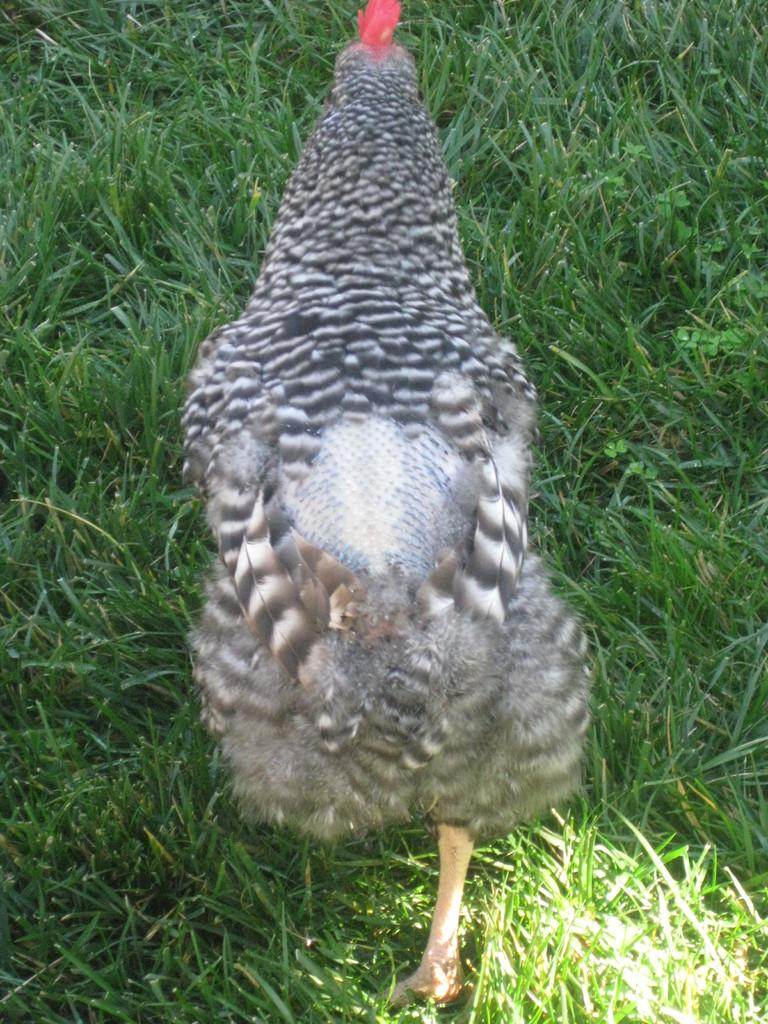What type of animal is in the image? There is a hen in the image. What color is the hen in the image? The hen is in black and white color. What is the hen walking on in the image? The hen is walking on grass in the image. What type of apparel is the hen wearing in the image? There is no apparel present on the hen in the image, as it is a bird and does not wear clothing. 